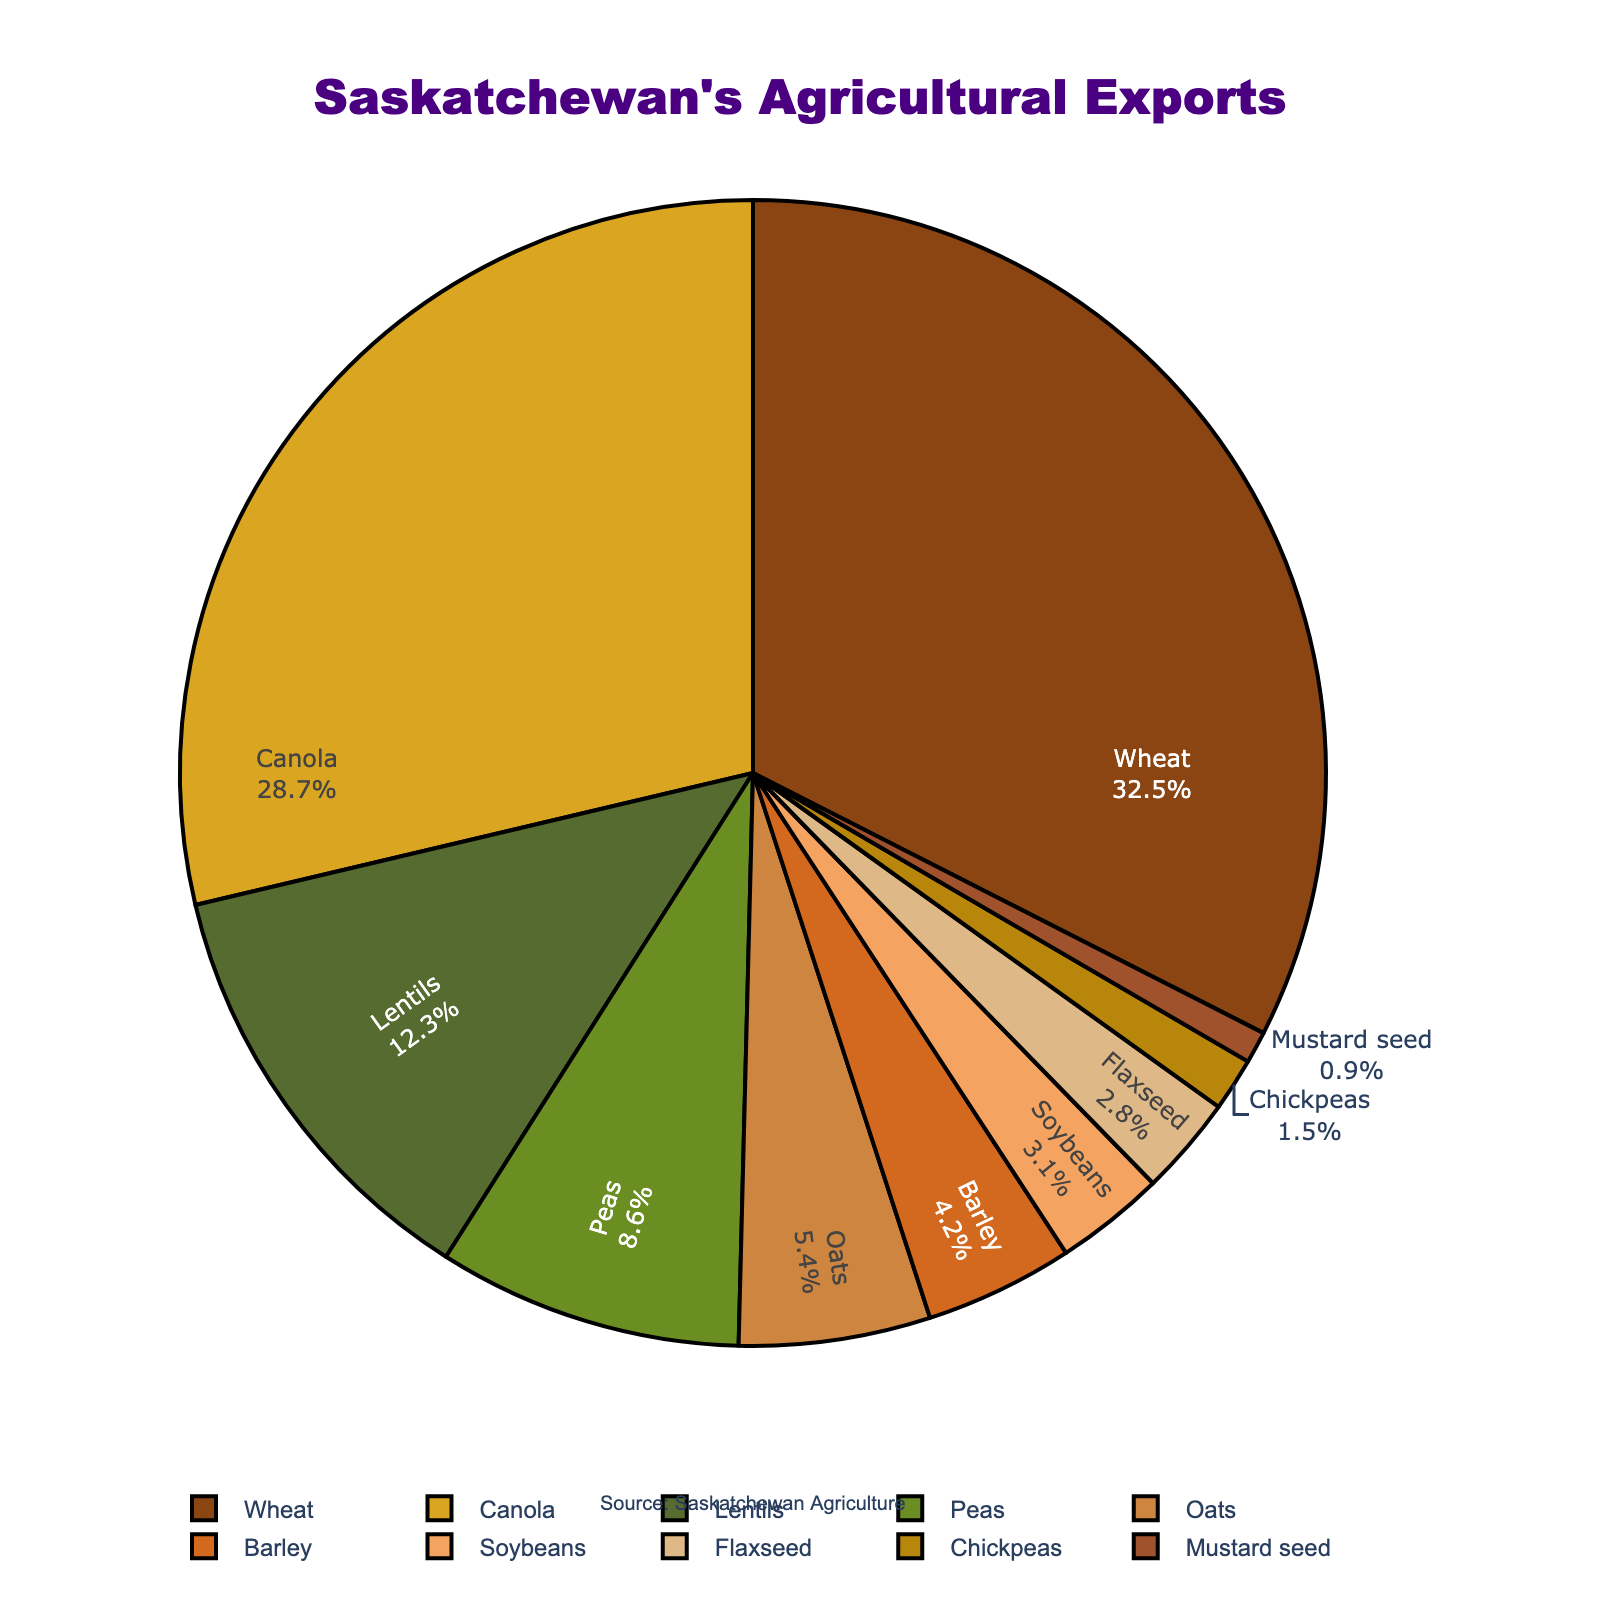What is the primary agricultural export product of Saskatchewan? The pie chart shows the largest segment, which represents the product with the highest percentage. In this case, it is Wheat with 32.5%.
Answer: Wheat Which product has a greater export percentage, Canola or Lentils? By comparing the percentages from the pie chart, Canola has 28.7%, which is greater than Lentils at 12.3%.
Answer: Canola How much greater is the export percentage of Wheat compared to Peas? To find the difference, subtract the percentage of Peas from Wheat (32.5% - 8.6% = 23.9%).
Answer: 23.9% What is the combined export percentage of Oats and Barley? Sum the percentages of Oats and Barley from the chart (5.4% + 4.2% = 9.6%).
Answer: 9.6% Which agricultural product has the smallest export share? The smallest segment on the pie chart represents Mustard Seed with 0.9%.
Answer: Mustard Seed Is the export percentage of Soybeans greater than Flaxseed? If yes, by how much? Soybeans have 3.1% and Flaxseed has 2.8%. Subtracting these gives the difference (3.1% - 2.8% = 0.3%).
Answer: Yes, by 0.3% How do the percentages of Canola and Wheat together compare with the rest of the products? Add Canola and Wheat percentages (28.7% + 32.5% = 61.2%) and compare with the sum of the remaining products' percentages (100% - 61.2% = 38.8%).
Answer: They are higher by 22.4% What is the average percentage of the three smallest export products? Identify the three smallest products: Chickpeas (1.5%), Mustard Seed (0.9%), and Flaxseed (2.8%). Average = (1.5% + 0.9% + 2.8%)/3 = 1.73%.
Answer: 1.73% What is the second smallest product category in terms of percentage? The pie chart shows the second smallest segment is Chickpeas with 1.5%.
Answer: Chickpeas Which product has a larger export percentage, Oats or Soybeans? Oats have 5.4% and Soybeans have 3.1%. Comparing these, Oats have a larger percentage.
Answer: Oats 